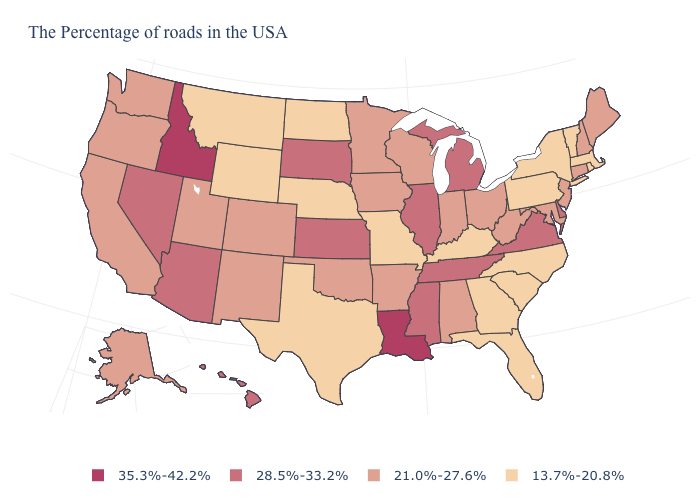What is the value of Ohio?
Concise answer only. 21.0%-27.6%. What is the value of Hawaii?
Keep it brief. 28.5%-33.2%. What is the value of New Hampshire?
Concise answer only. 21.0%-27.6%. Which states hav the highest value in the Northeast?
Short answer required. Maine, New Hampshire, Connecticut, New Jersey. What is the value of New York?
Short answer required. 13.7%-20.8%. Name the states that have a value in the range 21.0%-27.6%?
Quick response, please. Maine, New Hampshire, Connecticut, New Jersey, Maryland, West Virginia, Ohio, Indiana, Alabama, Wisconsin, Arkansas, Minnesota, Iowa, Oklahoma, Colorado, New Mexico, Utah, California, Washington, Oregon, Alaska. What is the value of Hawaii?
Be succinct. 28.5%-33.2%. Does Massachusetts have a lower value than South Carolina?
Keep it brief. No. Name the states that have a value in the range 35.3%-42.2%?
Quick response, please. Louisiana, Idaho. Among the states that border New Hampshire , does Maine have the highest value?
Answer briefly. Yes. What is the highest value in the USA?
Write a very short answer. 35.3%-42.2%. What is the value of Georgia?
Be succinct. 13.7%-20.8%. Among the states that border Missouri , which have the highest value?
Write a very short answer. Tennessee, Illinois, Kansas. Does Indiana have the same value as Maine?
Give a very brief answer. Yes. Which states hav the highest value in the Northeast?
Short answer required. Maine, New Hampshire, Connecticut, New Jersey. 